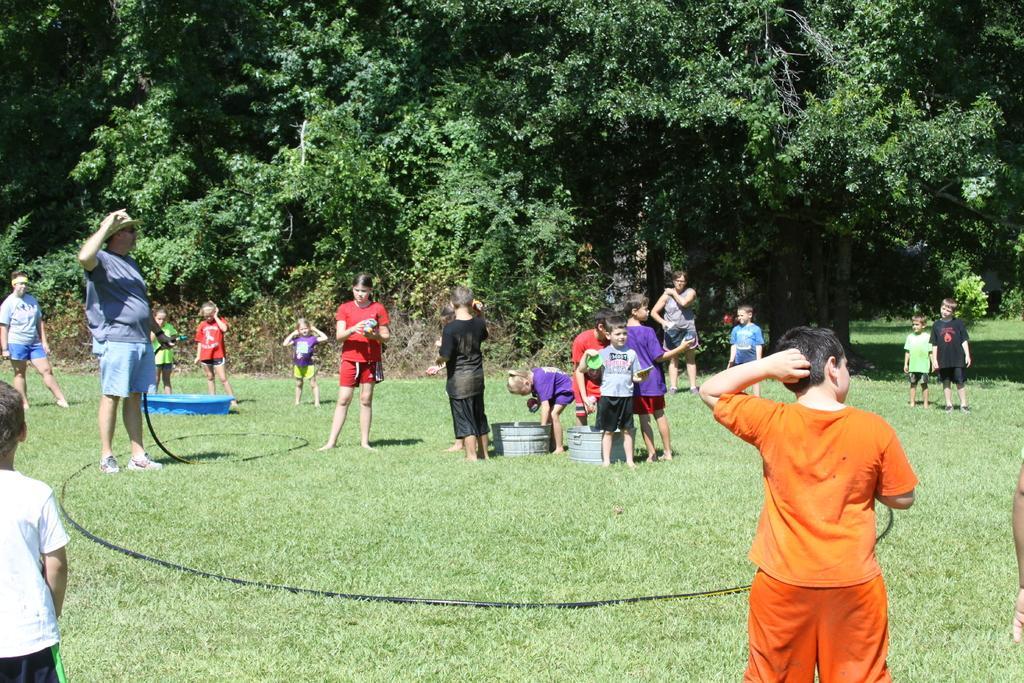Describe this image in one or two sentences. In this picture we can see some people standing here, at the bottom there is grass, we can see a pipe here, in the background there are trees. 